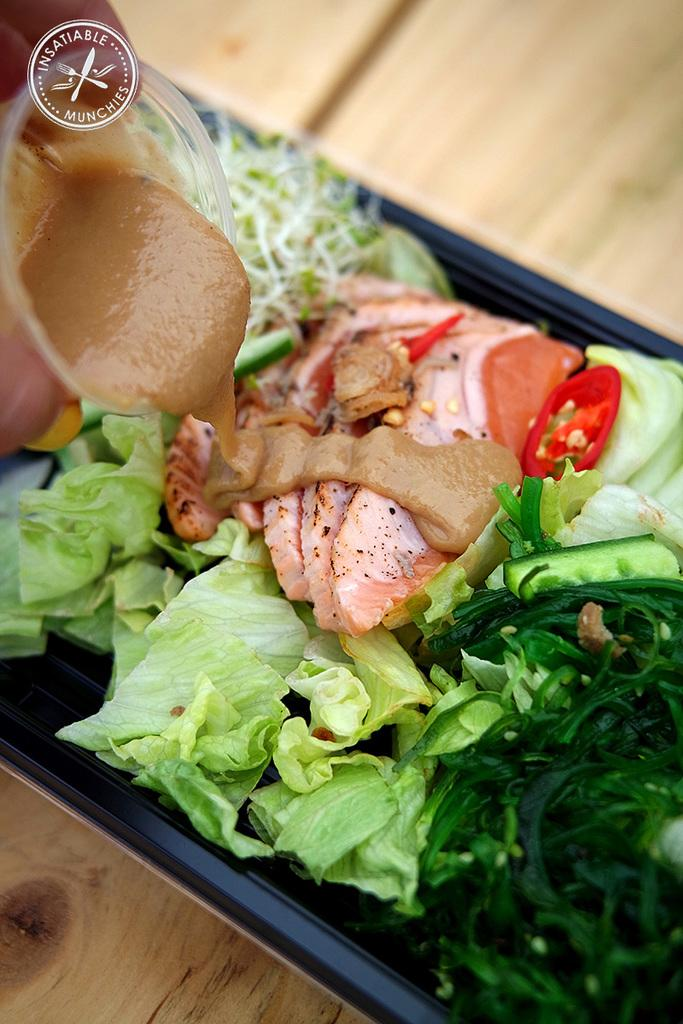What is on the plate that is visible in the image? There is food in a plate in the image. What is the plate placed on? The plate is placed on a wooden surface. Whose hand is holding a glass in the image? There is a person's hand holding a glass in the image. What is in the glass that the person is holding? The glass contains sauce. What type of plastic is used to make the rice in the image? There is no plastic or rice present in the image. What cast member from the movie "The Lion King" can be seen in the image? There are no cast members or movie references present in the image. 